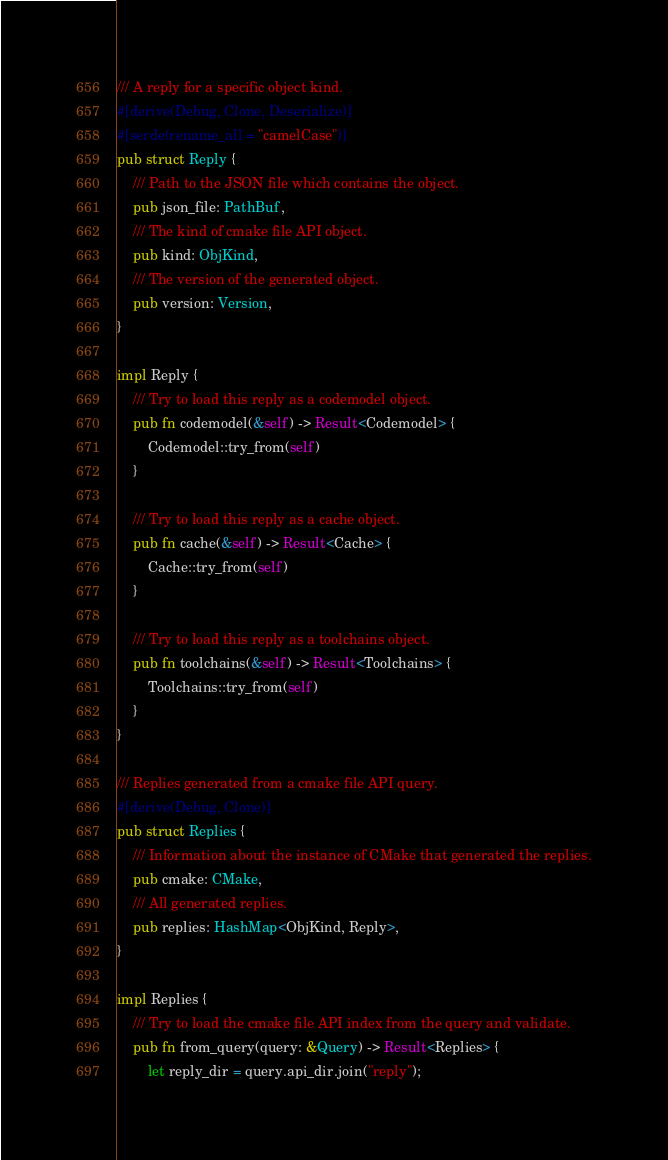<code> <loc_0><loc_0><loc_500><loc_500><_Rust_>/// A reply for a specific object kind.
#[derive(Debug, Clone, Deserialize)]
#[serde(rename_all = "camelCase")]
pub struct Reply {
    /// Path to the JSON file which contains the object.
    pub json_file: PathBuf,
    /// The kind of cmake file API object.
    pub kind: ObjKind,
    /// The version of the generated object.
    pub version: Version,
}

impl Reply {
    /// Try to load this reply as a codemodel object.
    pub fn codemodel(&self) -> Result<Codemodel> {
        Codemodel::try_from(self)
    }

    /// Try to load this reply as a cache object.
    pub fn cache(&self) -> Result<Cache> {
        Cache::try_from(self)
    }

    /// Try to load this reply as a toolchains object.
    pub fn toolchains(&self) -> Result<Toolchains> {
        Toolchains::try_from(self)
    }
}

/// Replies generated from a cmake file API query.
#[derive(Debug, Clone)]
pub struct Replies {
    /// Information about the instance of CMake that generated the replies.
    pub cmake: CMake,
    /// All generated replies.
    pub replies: HashMap<ObjKind, Reply>,
}

impl Replies {
    /// Try to load the cmake file API index from the query and validate.
    pub fn from_query(query: &Query) -> Result<Replies> {
        let reply_dir = query.api_dir.join("reply");
</code> 